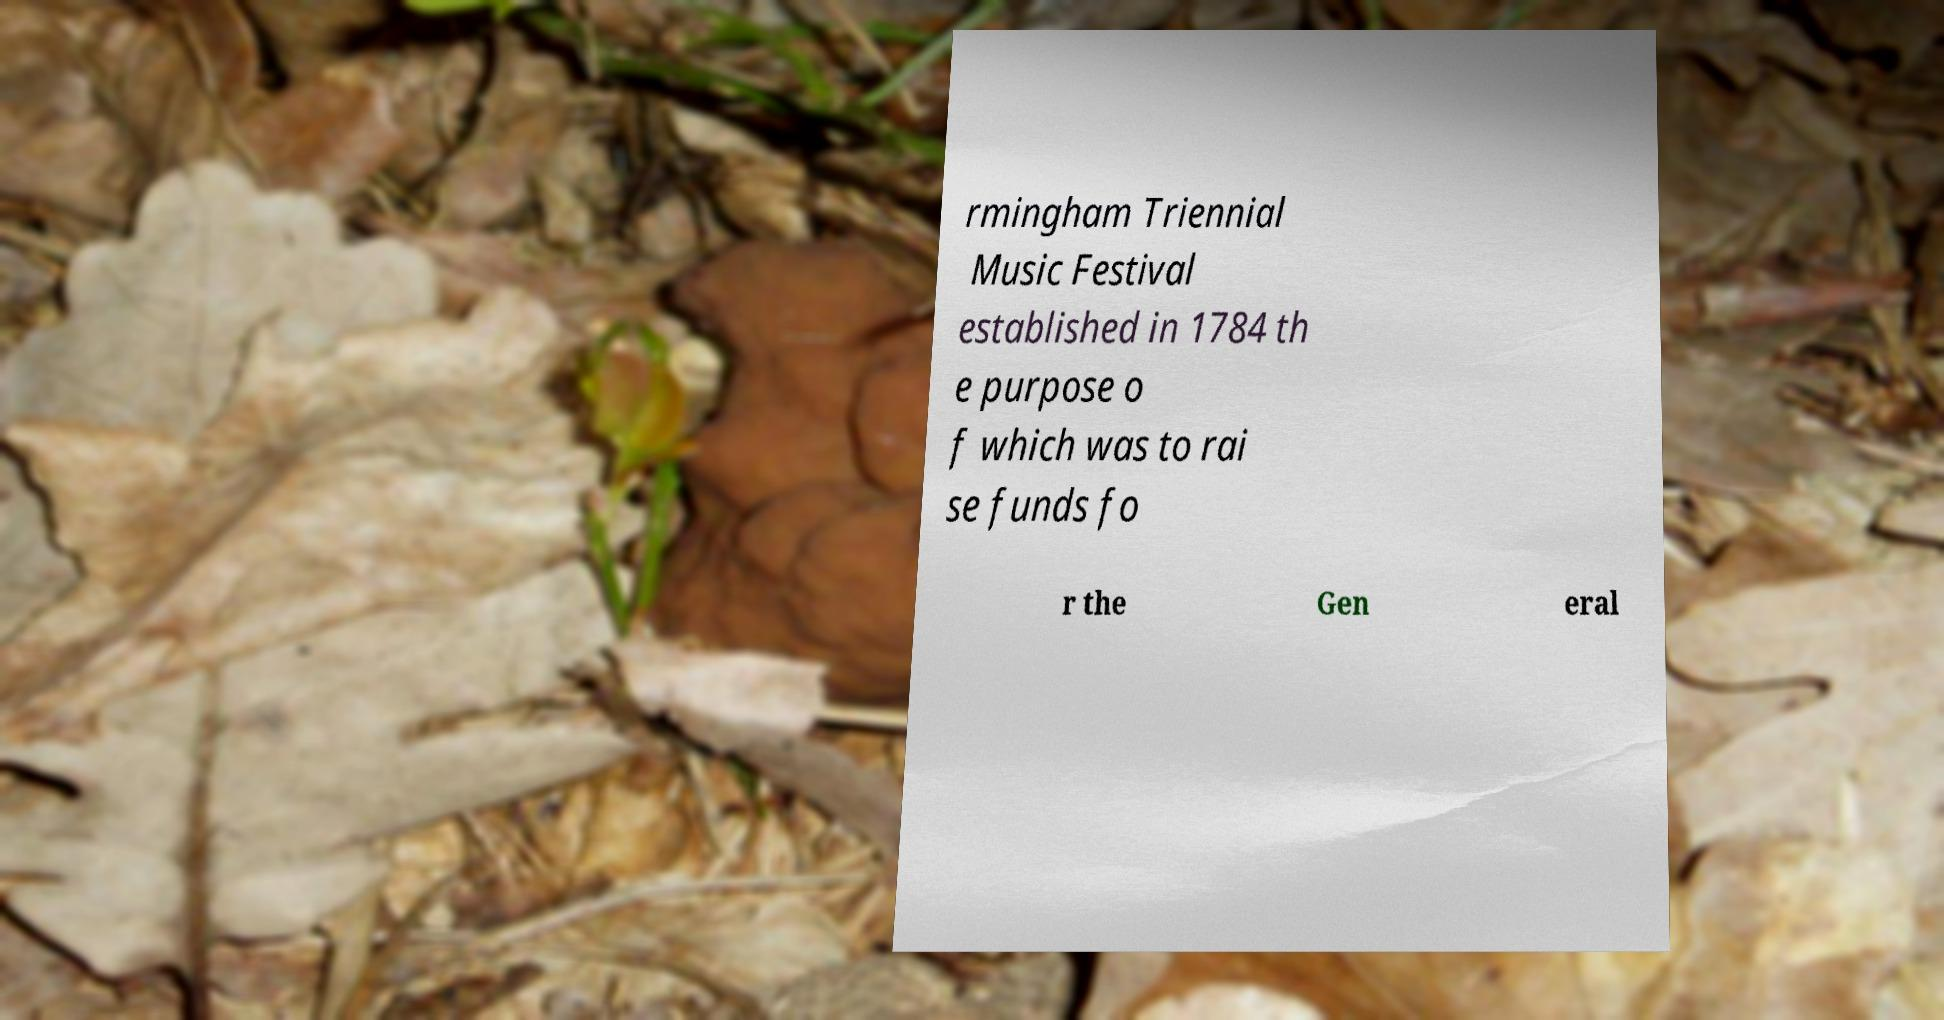I need the written content from this picture converted into text. Can you do that? rmingham Triennial Music Festival established in 1784 th e purpose o f which was to rai se funds fo r the Gen eral 